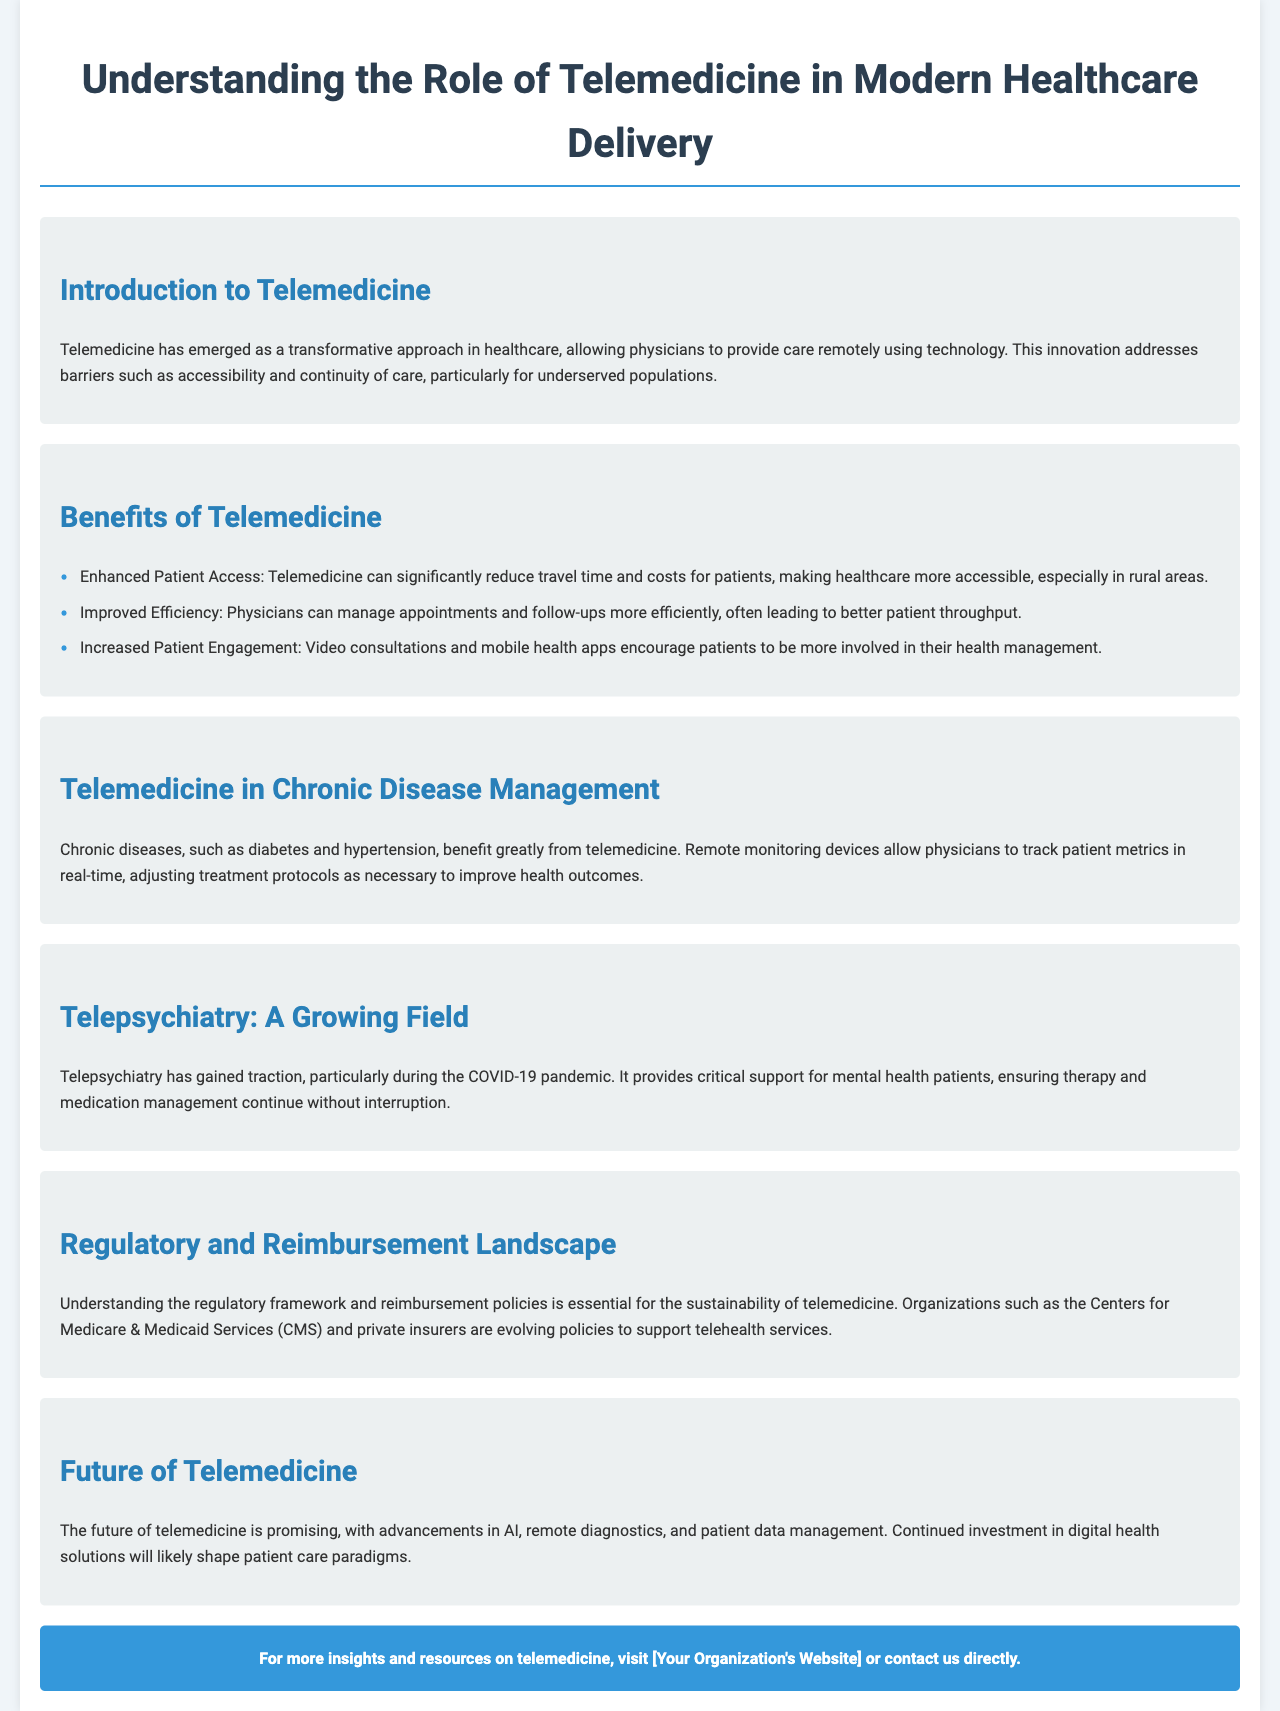What is the main focus of telemedicine? The introduction indicates that telemedicine focuses on providing care remotely using technology.
Answer: Providing care remotely using technology What are two key benefits of telemedicine mentioned? The document lists benefits such as enhanced patient access and improved efficiency.
Answer: Enhanced Patient Access and Improved Efficiency Which patient demographic particularly benefits from telemedicine? The introduction states that telemedicine helps underserved populations.
Answer: Underserved populations What chronic diseases are noted to benefit from telemedicine? The document specifically mentions chronic diseases like diabetes and hypertension.
Answer: Diabetes and hypertension What has fueled the growth of telepsychiatry? The text highlights the COVID-19 pandemic as a significant factor in the growth of telepsychiatry.
Answer: COVID-19 pandemic Which organization is mentioned in the regulatory landscape of telemedicine? The document mentions the Centers for Medicare & Medicaid Services (CMS) in relation to telemedicine regulations.
Answer: Centers for Medicare & Medicaid Services (CMS) What technological advancements are expected to shape the future of telemedicine? The future section discusses advancements in AI, remote diagnostics, and patient data management.
Answer: AI, remote diagnostics, and patient data management What is suggested for further insights on telemedicine? The call to action advises visiting the organization’s website or contacting them directly for resources.
Answer: Visit [Your Organization's Website] or contact us directly 